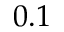Convert formula to latex. <formula><loc_0><loc_0><loc_500><loc_500>0 . 1</formula> 